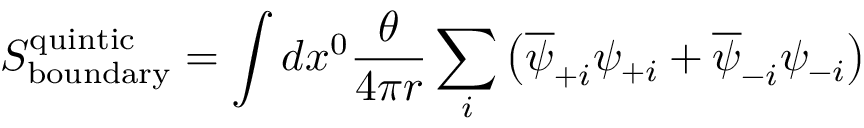Convert formula to latex. <formula><loc_0><loc_0><loc_500><loc_500>S _ { b o u n d a r y } ^ { q u i n t i c } = \int d x ^ { 0 } \frac { \theta } { 4 \pi r } \sum _ { i } \left ( \overline { \psi } _ { + i } \psi _ { + i } + \overline { \psi } _ { - i } \psi _ { - i } \right )</formula> 